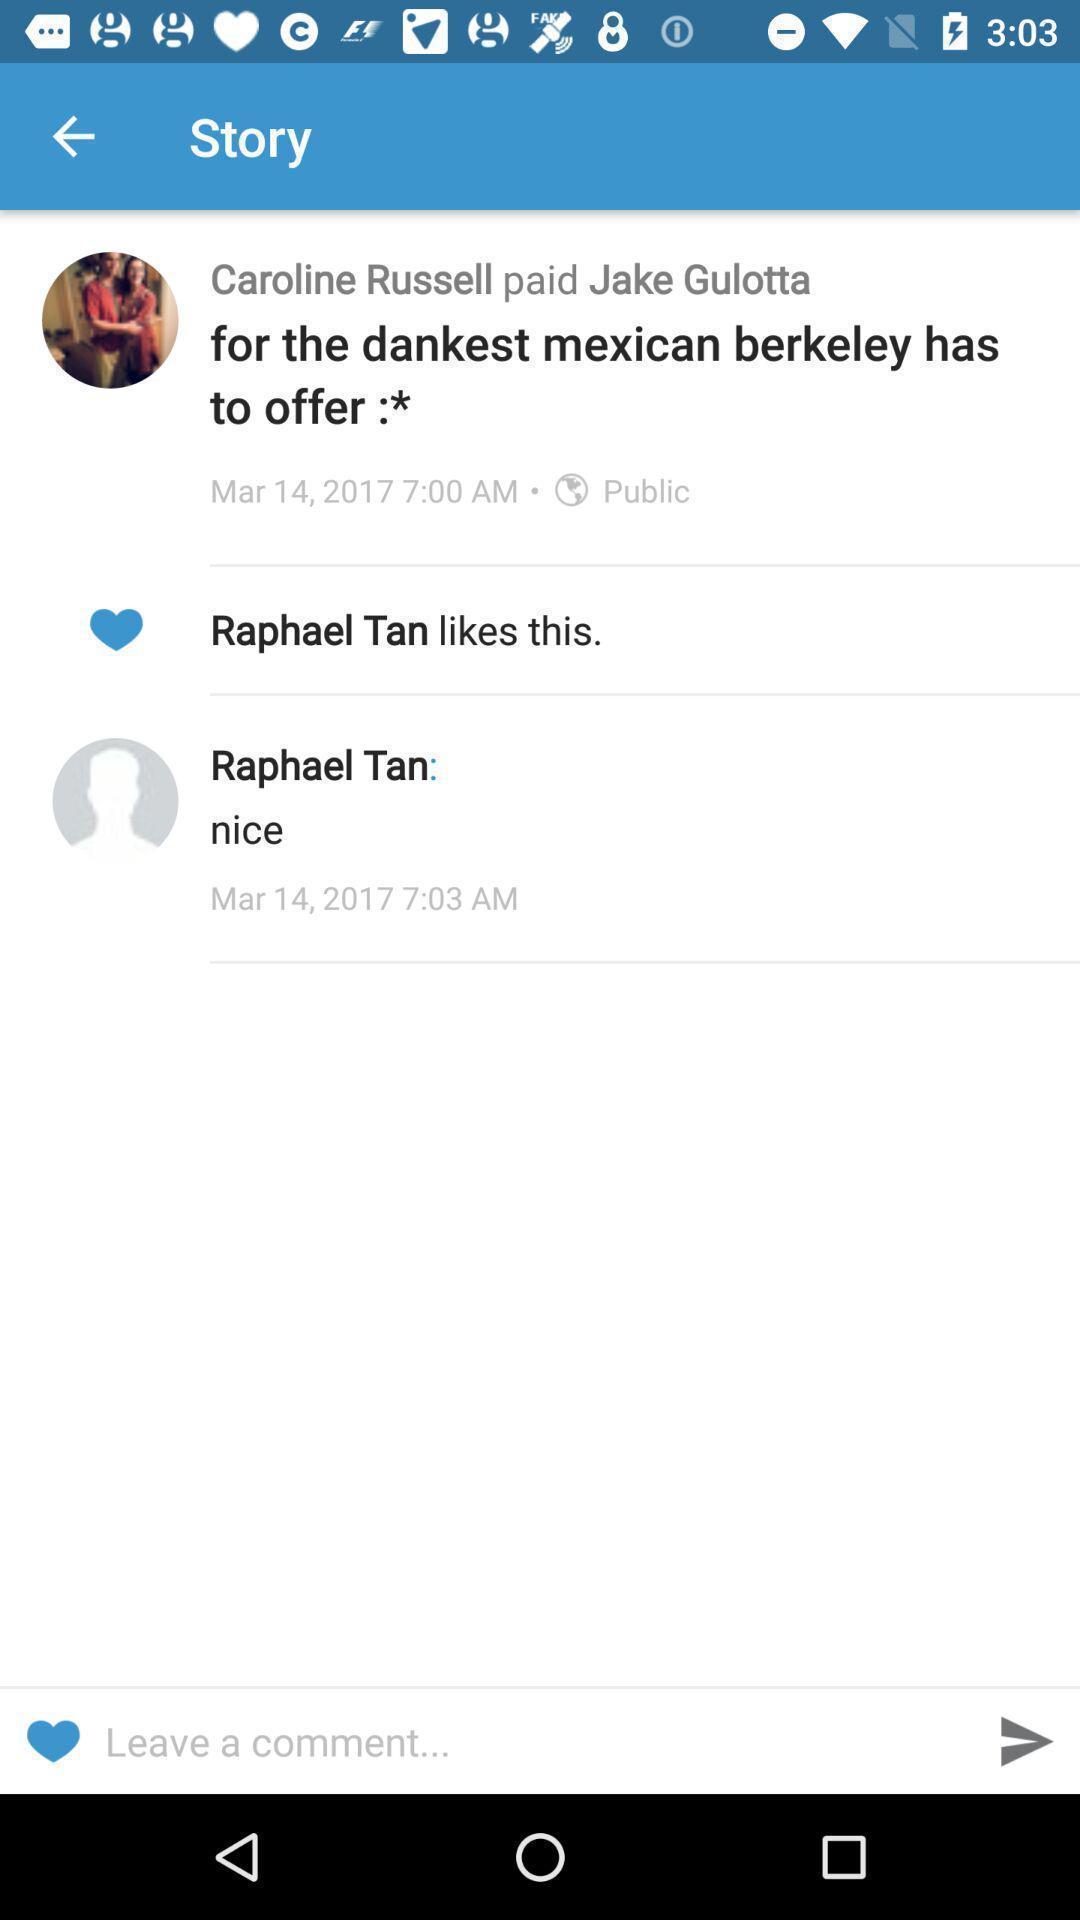Tell me about the visual elements in this screen capture. Screen shows a comment box in a social media app. 